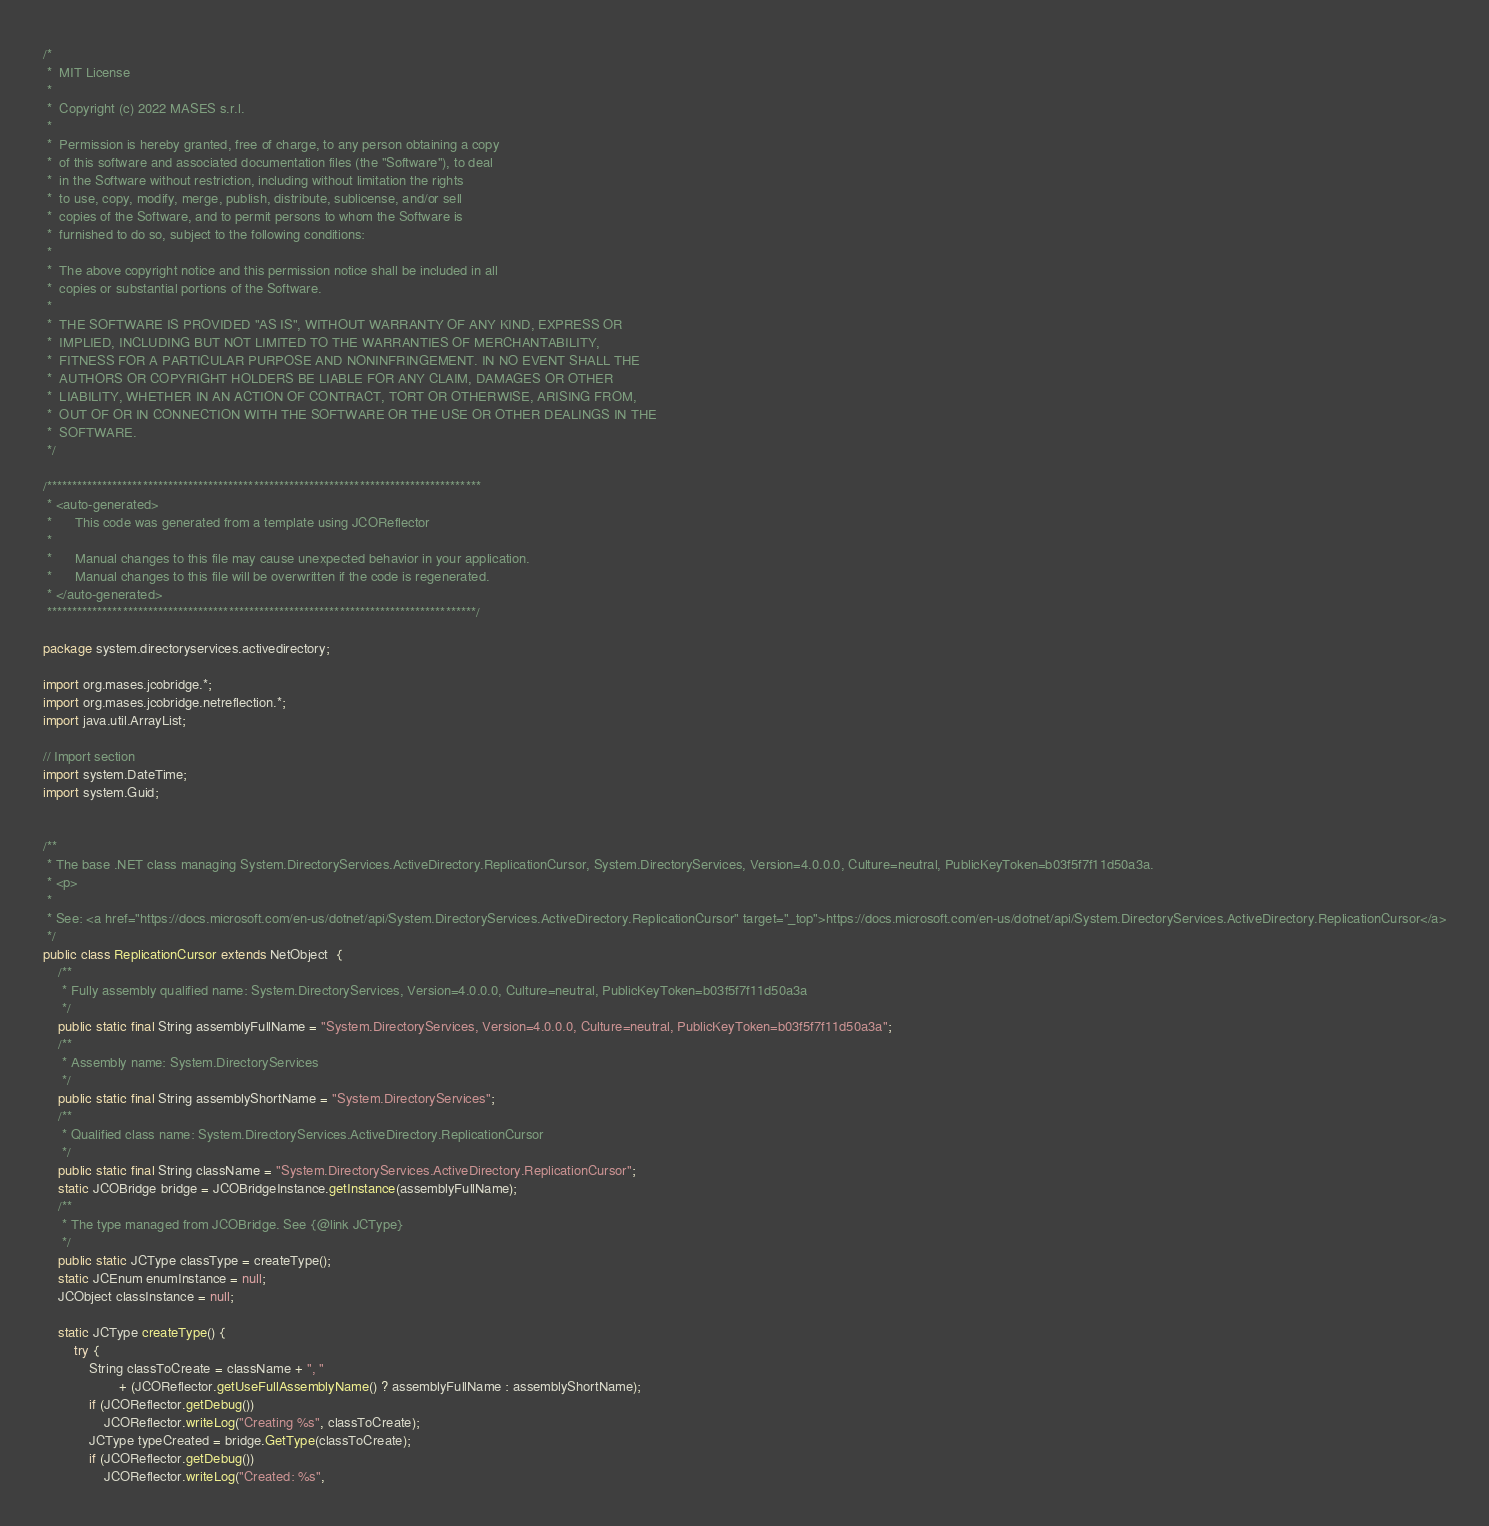Convert code to text. <code><loc_0><loc_0><loc_500><loc_500><_Java_>/*
 *  MIT License
 *
 *  Copyright (c) 2022 MASES s.r.l.
 *
 *  Permission is hereby granted, free of charge, to any person obtaining a copy
 *  of this software and associated documentation files (the "Software"), to deal
 *  in the Software without restriction, including without limitation the rights
 *  to use, copy, modify, merge, publish, distribute, sublicense, and/or sell
 *  copies of the Software, and to permit persons to whom the Software is
 *  furnished to do so, subject to the following conditions:
 *
 *  The above copyright notice and this permission notice shall be included in all
 *  copies or substantial portions of the Software.
 *
 *  THE SOFTWARE IS PROVIDED "AS IS", WITHOUT WARRANTY OF ANY KIND, EXPRESS OR
 *  IMPLIED, INCLUDING BUT NOT LIMITED TO THE WARRANTIES OF MERCHANTABILITY,
 *  FITNESS FOR A PARTICULAR PURPOSE AND NONINFRINGEMENT. IN NO EVENT SHALL THE
 *  AUTHORS OR COPYRIGHT HOLDERS BE LIABLE FOR ANY CLAIM, DAMAGES OR OTHER
 *  LIABILITY, WHETHER IN AN ACTION OF CONTRACT, TORT OR OTHERWISE, ARISING FROM,
 *  OUT OF OR IN CONNECTION WITH THE SOFTWARE OR THE USE OR OTHER DEALINGS IN THE
 *  SOFTWARE.
 */

/**************************************************************************************
 * <auto-generated>
 *      This code was generated from a template using JCOReflector
 * 
 *      Manual changes to this file may cause unexpected behavior in your application.
 *      Manual changes to this file will be overwritten if the code is regenerated.
 * </auto-generated>
 *************************************************************************************/

package system.directoryservices.activedirectory;

import org.mases.jcobridge.*;
import org.mases.jcobridge.netreflection.*;
import java.util.ArrayList;

// Import section
import system.DateTime;
import system.Guid;


/**
 * The base .NET class managing System.DirectoryServices.ActiveDirectory.ReplicationCursor, System.DirectoryServices, Version=4.0.0.0, Culture=neutral, PublicKeyToken=b03f5f7f11d50a3a.
 * <p>
 * 
 * See: <a href="https://docs.microsoft.com/en-us/dotnet/api/System.DirectoryServices.ActiveDirectory.ReplicationCursor" target="_top">https://docs.microsoft.com/en-us/dotnet/api/System.DirectoryServices.ActiveDirectory.ReplicationCursor</a>
 */
public class ReplicationCursor extends NetObject  {
    /**
     * Fully assembly qualified name: System.DirectoryServices, Version=4.0.0.0, Culture=neutral, PublicKeyToken=b03f5f7f11d50a3a
     */
    public static final String assemblyFullName = "System.DirectoryServices, Version=4.0.0.0, Culture=neutral, PublicKeyToken=b03f5f7f11d50a3a";
    /**
     * Assembly name: System.DirectoryServices
     */
    public static final String assemblyShortName = "System.DirectoryServices";
    /**
     * Qualified class name: System.DirectoryServices.ActiveDirectory.ReplicationCursor
     */
    public static final String className = "System.DirectoryServices.ActiveDirectory.ReplicationCursor";
    static JCOBridge bridge = JCOBridgeInstance.getInstance(assemblyFullName);
    /**
     * The type managed from JCOBridge. See {@link JCType}
     */
    public static JCType classType = createType();
    static JCEnum enumInstance = null;
    JCObject classInstance = null;

    static JCType createType() {
        try {
            String classToCreate = className + ", "
                    + (JCOReflector.getUseFullAssemblyName() ? assemblyFullName : assemblyShortName);
            if (JCOReflector.getDebug())
                JCOReflector.writeLog("Creating %s", classToCreate);
            JCType typeCreated = bridge.GetType(classToCreate);
            if (JCOReflector.getDebug())
                JCOReflector.writeLog("Created: %s",</code> 